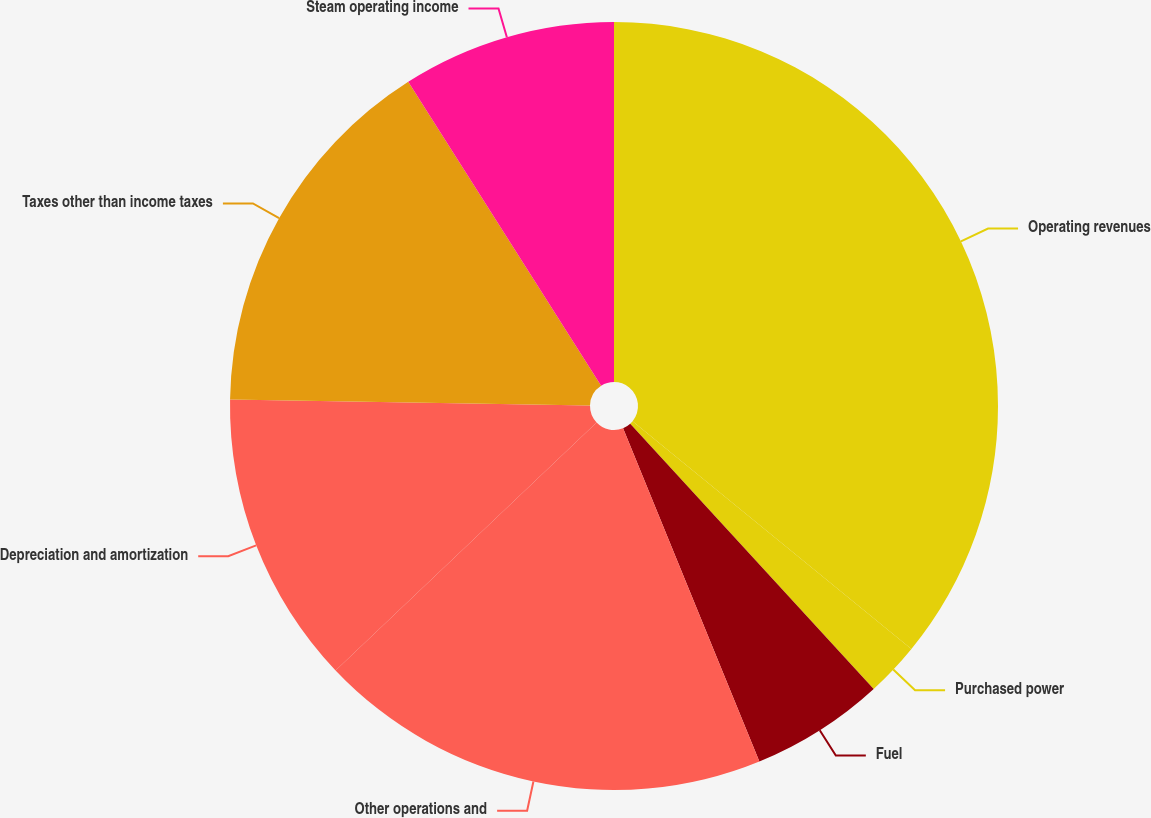Convert chart to OTSL. <chart><loc_0><loc_0><loc_500><loc_500><pie_chart><fcel>Operating revenues<fcel>Purchased power<fcel>Fuel<fcel>Other operations and<fcel>Depreciation and amortization<fcel>Taxes other than income taxes<fcel>Steam operating income<nl><fcel>35.9%<fcel>2.28%<fcel>5.64%<fcel>19.09%<fcel>12.36%<fcel>15.73%<fcel>9.0%<nl></chart> 